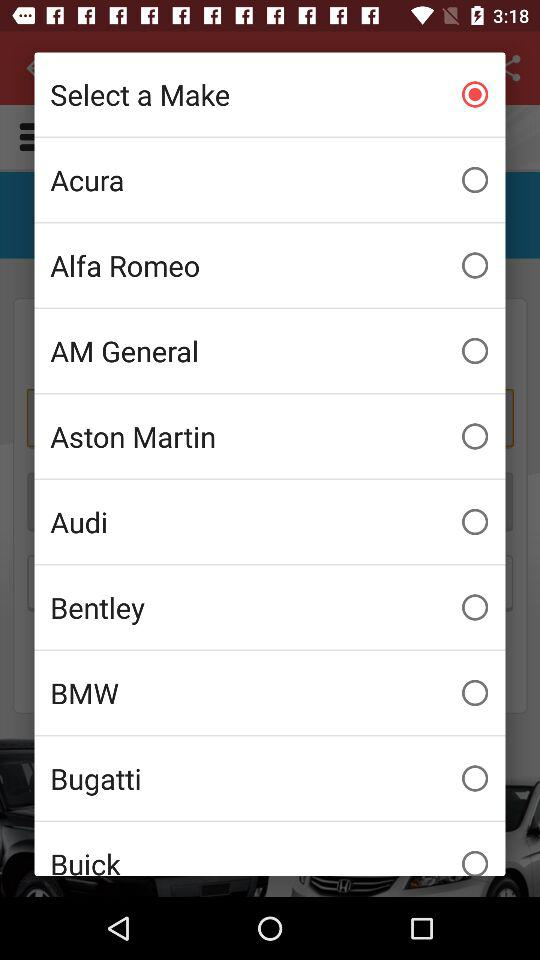What is the selected option? The selected option is "Select a Make". 